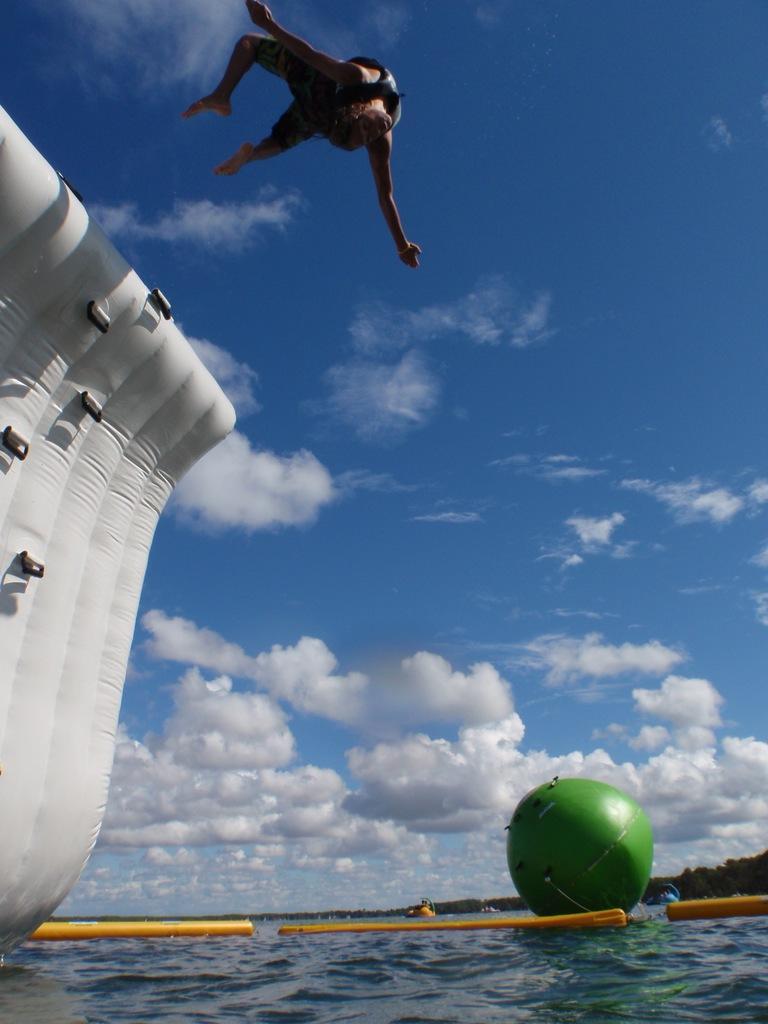Describe this image in one or two sentences. In this picture I can see water. I can see inflatable object. I can see clouds in the sky. I can see man. 